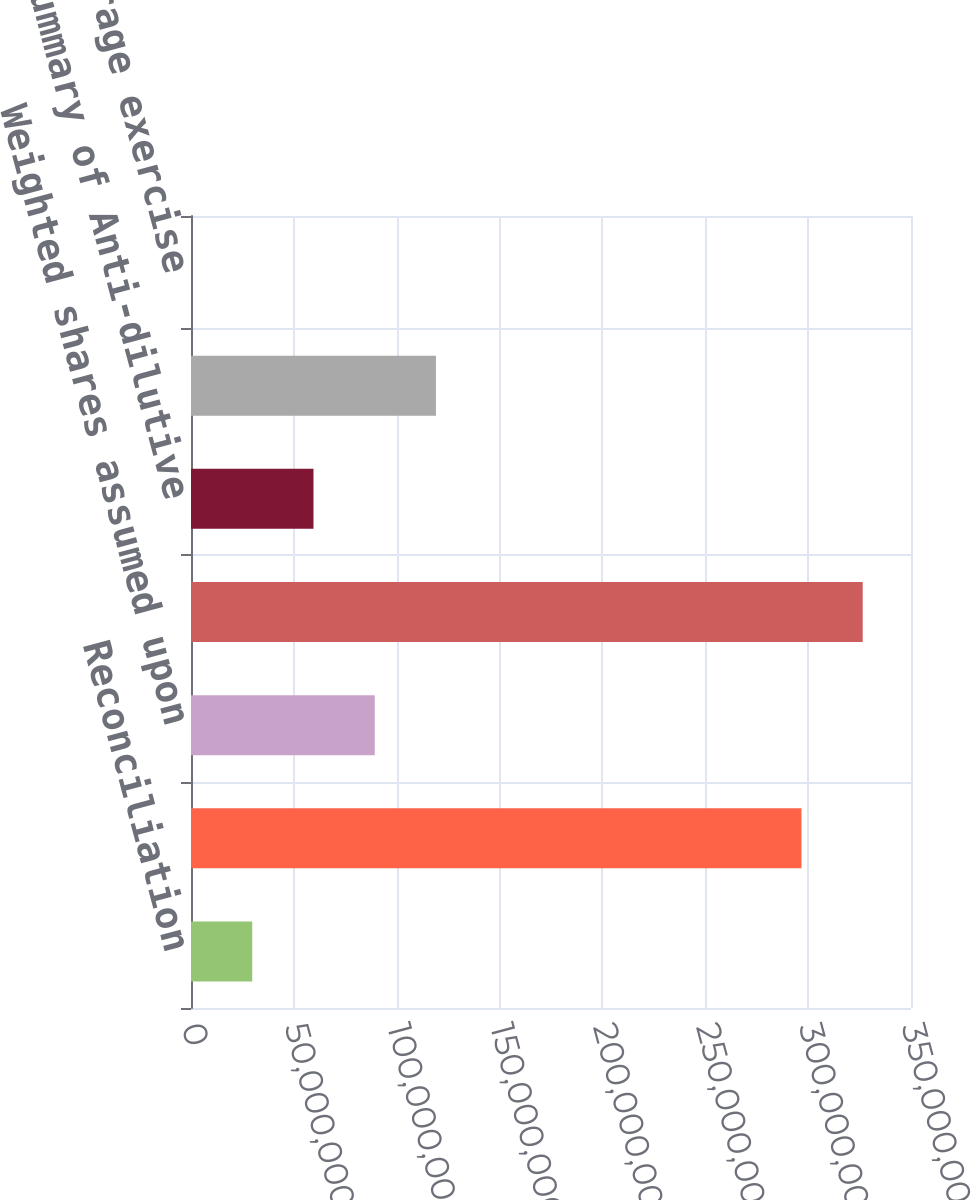Convert chart to OTSL. <chart><loc_0><loc_0><loc_500><loc_500><bar_chart><fcel>Reconciliation<fcel>Basic weighted average shares<fcel>Weighted shares assumed upon<fcel>Diluted weighted average<fcel>Summary of Anti-dilutive<fcel>Options to purchase shares of<fcel>Weighted average exercise<nl><fcel>2.97684e+07<fcel>2.96754e+08<fcel>8.93051e+07<fcel>3.26523e+08<fcel>5.95368e+07<fcel>1.19073e+08<fcel>54<nl></chart> 